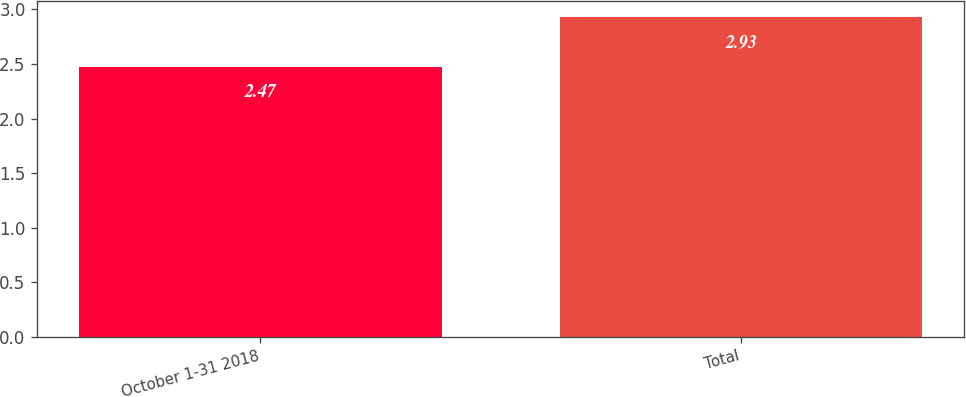<chart> <loc_0><loc_0><loc_500><loc_500><bar_chart><fcel>October 1-31 2018<fcel>Total<nl><fcel>2.47<fcel>2.93<nl></chart> 